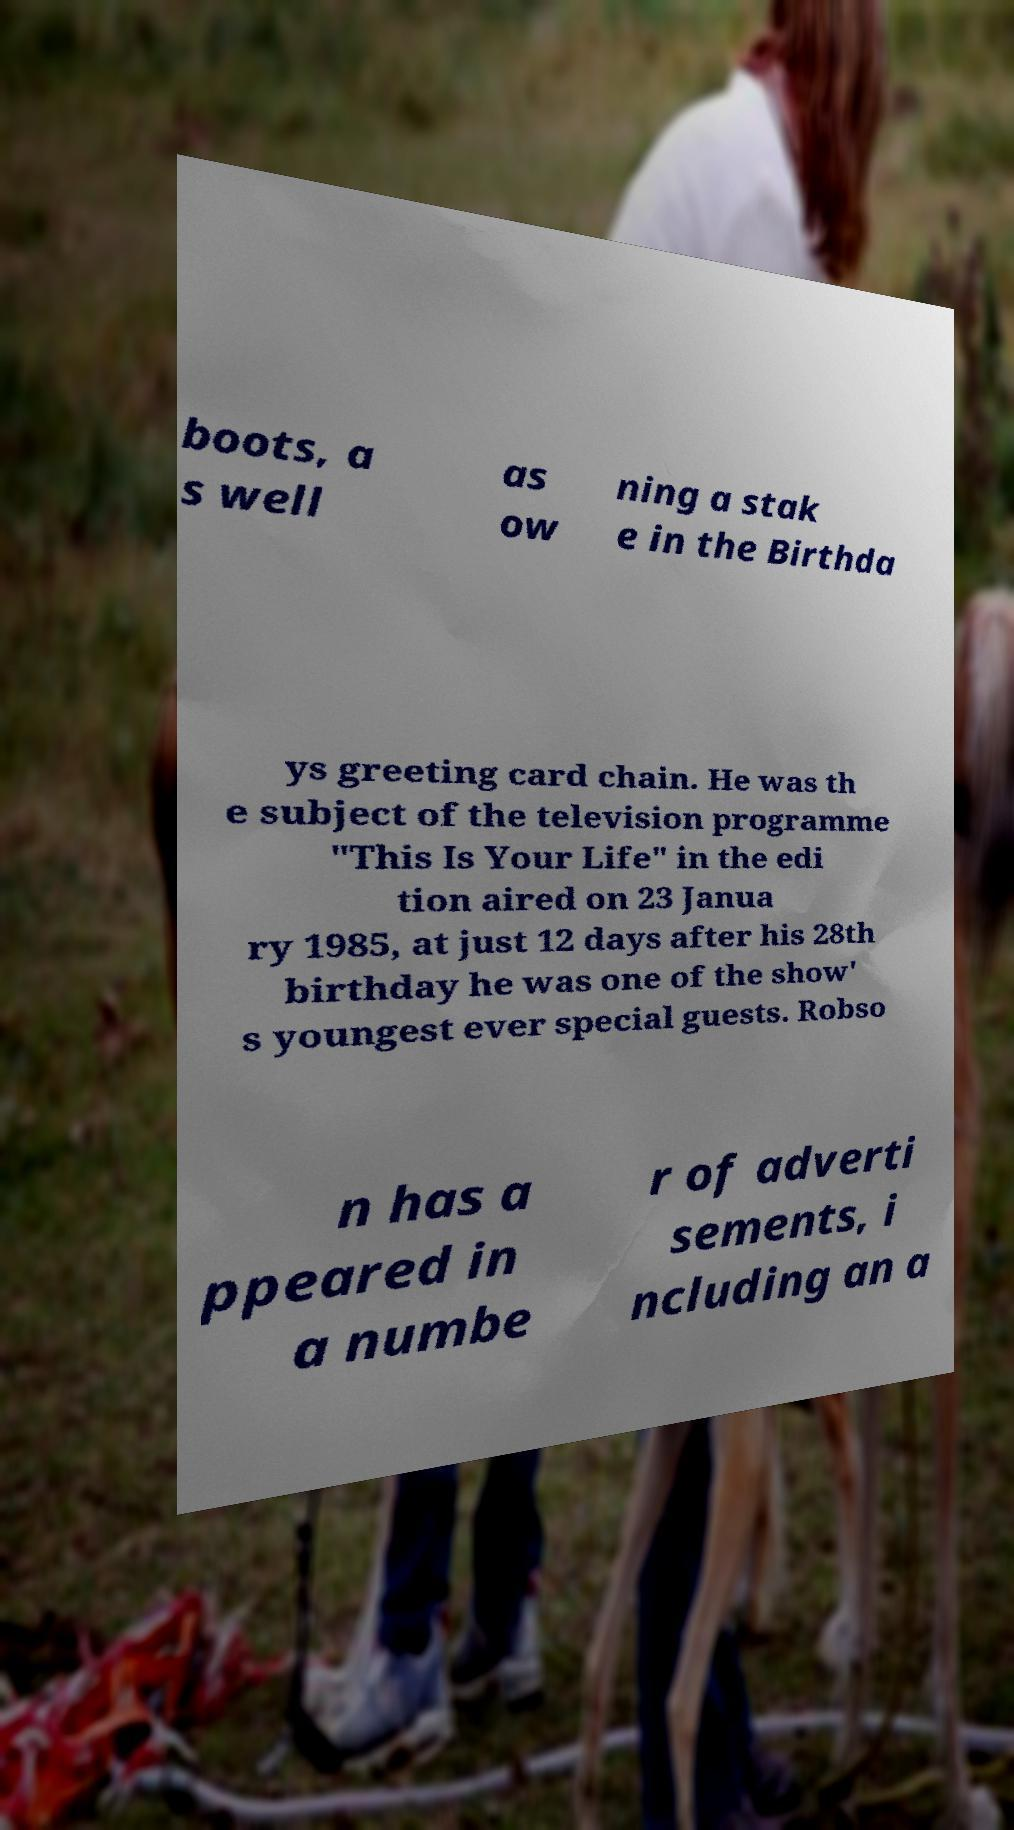Please read and relay the text visible in this image. What does it say? boots, a s well as ow ning a stak e in the Birthda ys greeting card chain. He was th e subject of the television programme "This Is Your Life" in the edi tion aired on 23 Janua ry 1985, at just 12 days after his 28th birthday he was one of the show' s youngest ever special guests. Robso n has a ppeared in a numbe r of adverti sements, i ncluding an a 